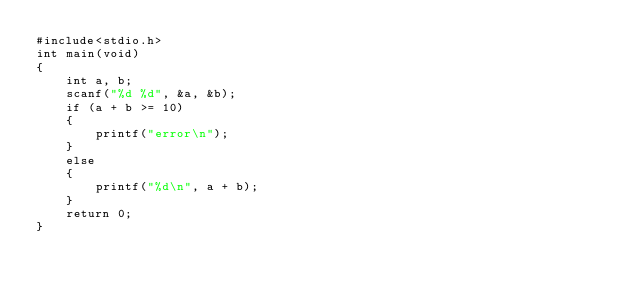Convert code to text. <code><loc_0><loc_0><loc_500><loc_500><_C_>#include<stdio.h>
int main(void)
{
	int a, b;
	scanf("%d %d", &a, &b);
	if (a + b >= 10)
	{
		printf("error\n");
	}
	else
	{
		printf("%d\n", a + b);
	}
	return 0;
}</code> 